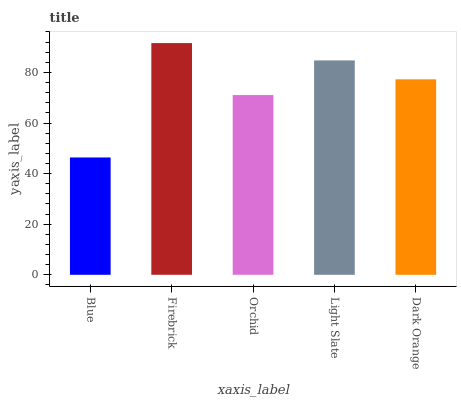Is Blue the minimum?
Answer yes or no. Yes. Is Firebrick the maximum?
Answer yes or no. Yes. Is Orchid the minimum?
Answer yes or no. No. Is Orchid the maximum?
Answer yes or no. No. Is Firebrick greater than Orchid?
Answer yes or no. Yes. Is Orchid less than Firebrick?
Answer yes or no. Yes. Is Orchid greater than Firebrick?
Answer yes or no. No. Is Firebrick less than Orchid?
Answer yes or no. No. Is Dark Orange the high median?
Answer yes or no. Yes. Is Dark Orange the low median?
Answer yes or no. Yes. Is Orchid the high median?
Answer yes or no. No. Is Blue the low median?
Answer yes or no. No. 